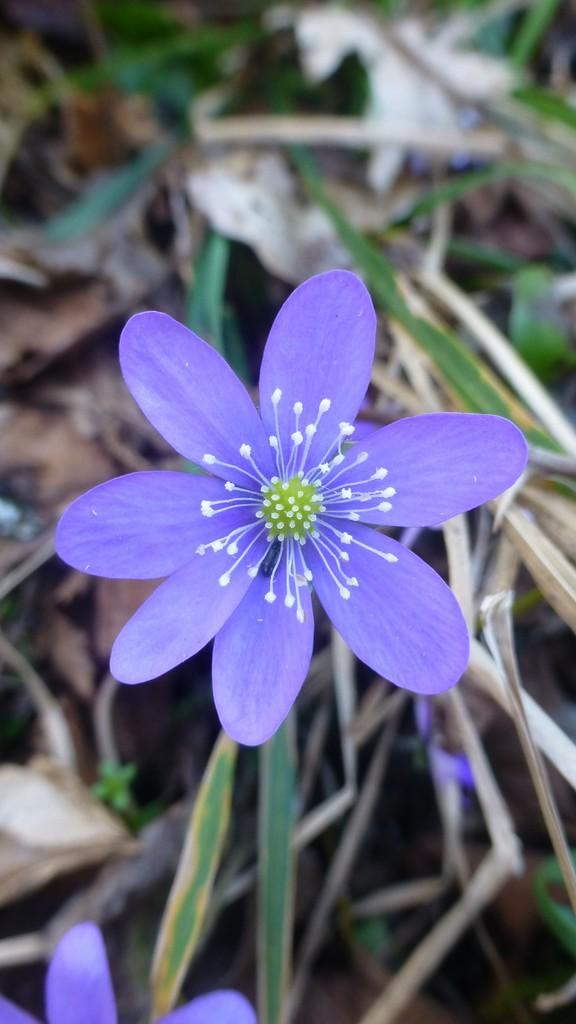What type of flower is in the image? There is a purple flower in the image. What is the flower situated on? The flower is on dry grassland. What type of chalk is being used to draw on the flower in the image? There is no chalk or drawing present in the image; it only features a purple flower on dry grassland. 